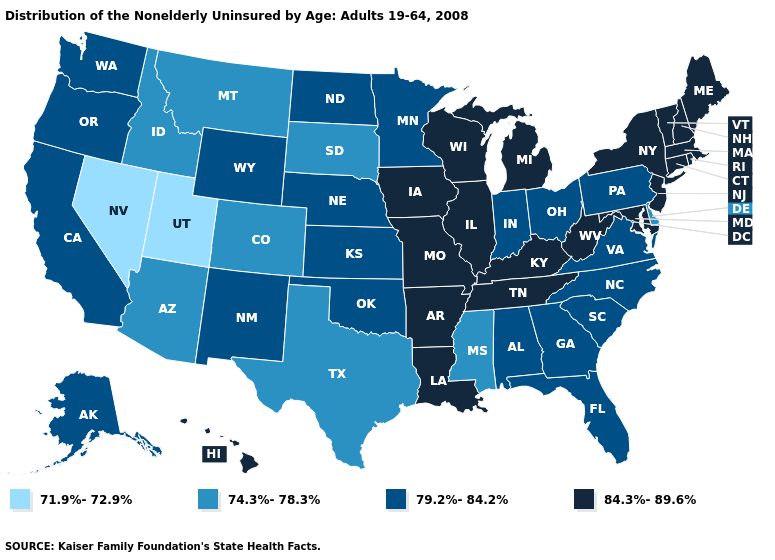What is the value of Utah?
Short answer required. 71.9%-72.9%. Name the states that have a value in the range 74.3%-78.3%?
Write a very short answer. Arizona, Colorado, Delaware, Idaho, Mississippi, Montana, South Dakota, Texas. Name the states that have a value in the range 84.3%-89.6%?
Be succinct. Arkansas, Connecticut, Hawaii, Illinois, Iowa, Kentucky, Louisiana, Maine, Maryland, Massachusetts, Michigan, Missouri, New Hampshire, New Jersey, New York, Rhode Island, Tennessee, Vermont, West Virginia, Wisconsin. Name the states that have a value in the range 71.9%-72.9%?
Write a very short answer. Nevada, Utah. Name the states that have a value in the range 71.9%-72.9%?
Answer briefly. Nevada, Utah. Name the states that have a value in the range 79.2%-84.2%?
Answer briefly. Alabama, Alaska, California, Florida, Georgia, Indiana, Kansas, Minnesota, Nebraska, New Mexico, North Carolina, North Dakota, Ohio, Oklahoma, Oregon, Pennsylvania, South Carolina, Virginia, Washington, Wyoming. What is the value of Mississippi?
Be succinct. 74.3%-78.3%. What is the value of South Dakota?
Short answer required. 74.3%-78.3%. What is the value of North Dakota?
Quick response, please. 79.2%-84.2%. Name the states that have a value in the range 79.2%-84.2%?
Concise answer only. Alabama, Alaska, California, Florida, Georgia, Indiana, Kansas, Minnesota, Nebraska, New Mexico, North Carolina, North Dakota, Ohio, Oklahoma, Oregon, Pennsylvania, South Carolina, Virginia, Washington, Wyoming. Name the states that have a value in the range 84.3%-89.6%?
Quick response, please. Arkansas, Connecticut, Hawaii, Illinois, Iowa, Kentucky, Louisiana, Maine, Maryland, Massachusetts, Michigan, Missouri, New Hampshire, New Jersey, New York, Rhode Island, Tennessee, Vermont, West Virginia, Wisconsin. Does Massachusetts have a higher value than South Carolina?
Write a very short answer. Yes. Does Hawaii have the highest value in the West?
Give a very brief answer. Yes. Does Pennsylvania have the highest value in the Northeast?
Give a very brief answer. No. 